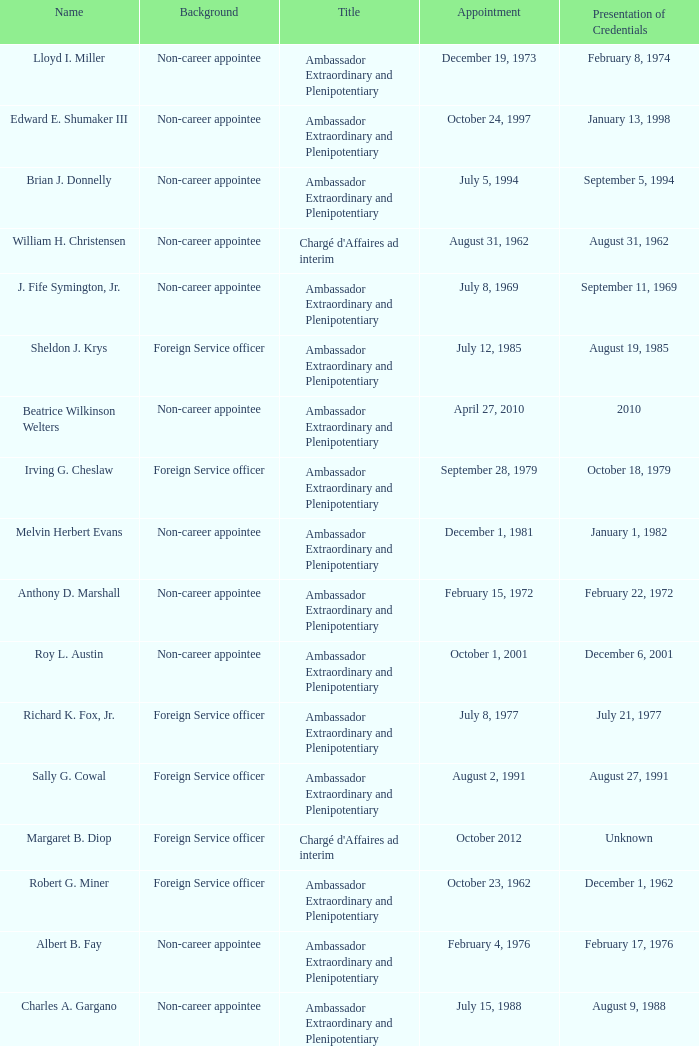What was Anthony D. Marshall's title? Ambassador Extraordinary and Plenipotentiary. 